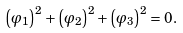<formula> <loc_0><loc_0><loc_500><loc_500>\left ( \varphi _ { 1 } \right ) ^ { 2 } + \left ( \varphi _ { 2 } \right ) ^ { 2 } + \left ( \varphi _ { 3 } \right ) ^ { 2 } = 0 .</formula> 